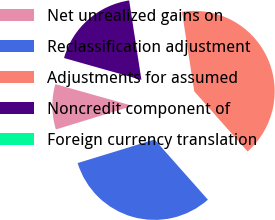<chart> <loc_0><loc_0><loc_500><loc_500><pie_chart><fcel>Net unrealized gains on<fcel>Reclassification adjustment<fcel>Adjustments for assumed<fcel>Noncredit component of<fcel>Foreign currency translation<nl><fcel>9.1%<fcel>31.81%<fcel>40.89%<fcel>18.18%<fcel>0.02%<nl></chart> 